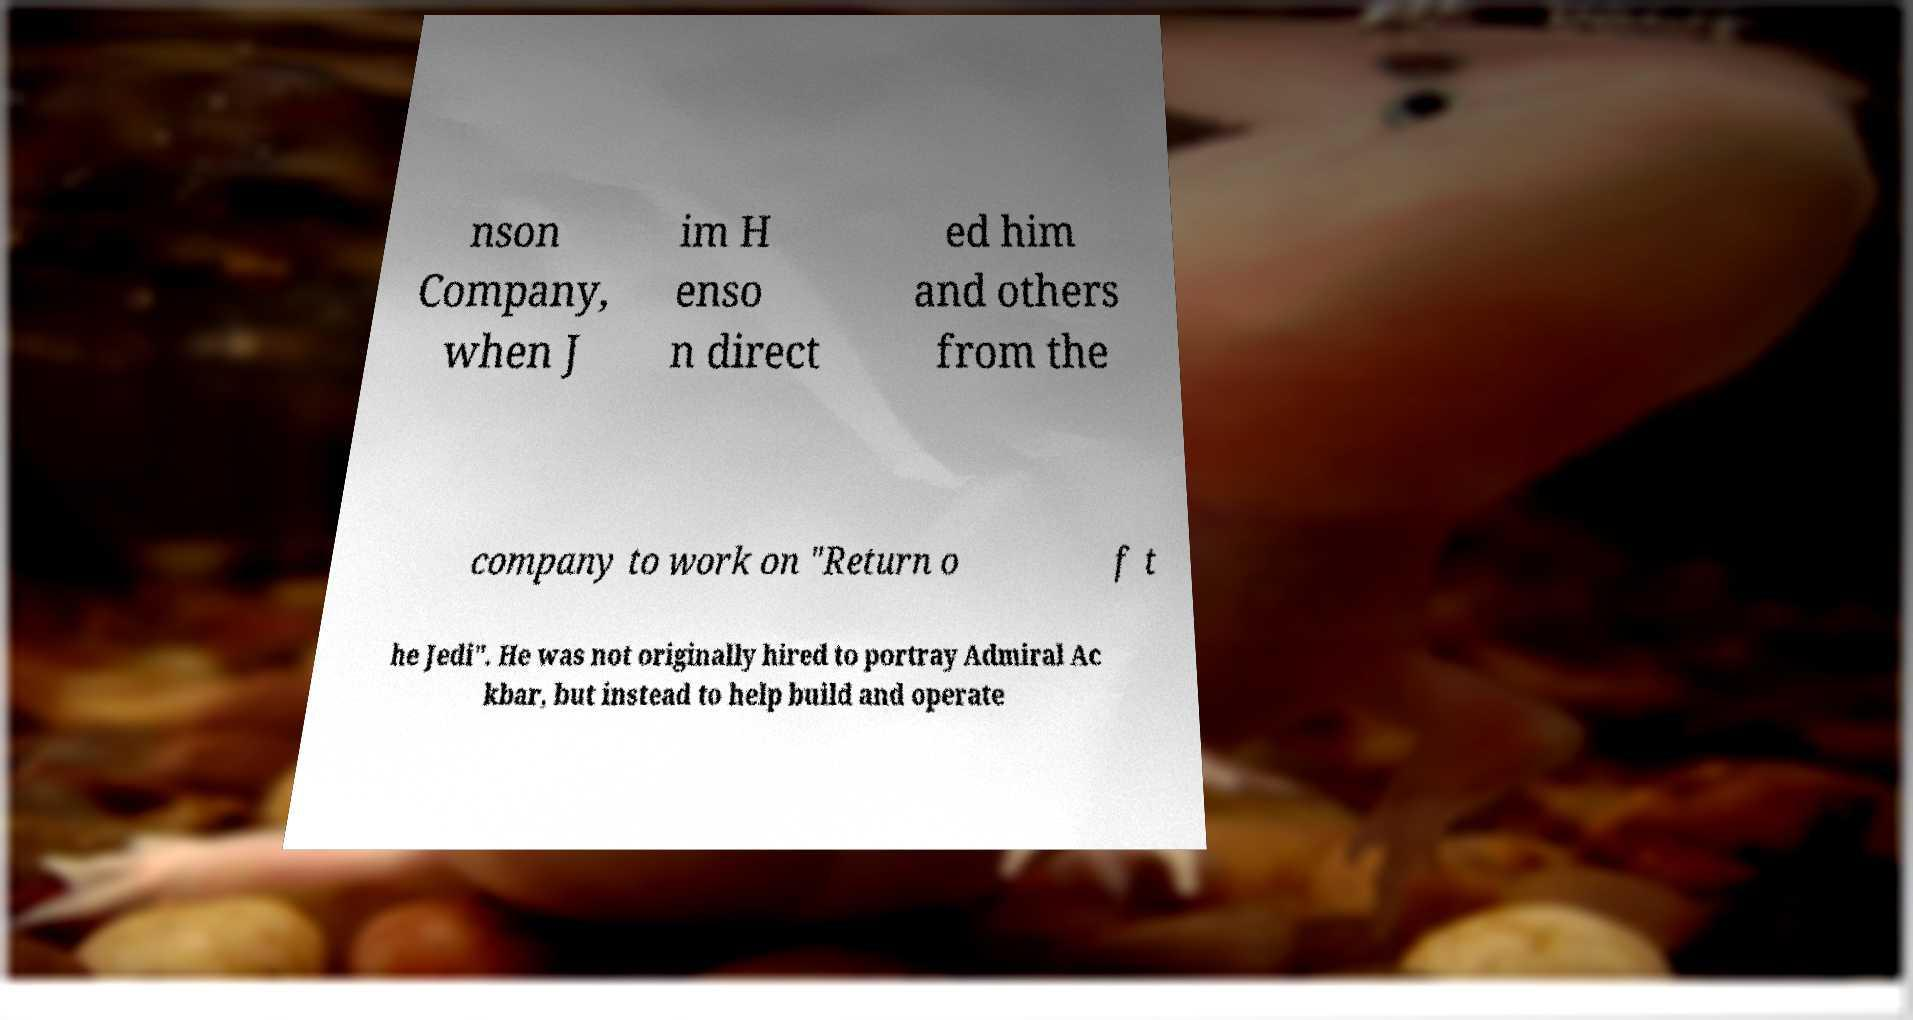Please identify and transcribe the text found in this image. nson Company, when J im H enso n direct ed him and others from the company to work on "Return o f t he Jedi". He was not originally hired to portray Admiral Ac kbar, but instead to help build and operate 